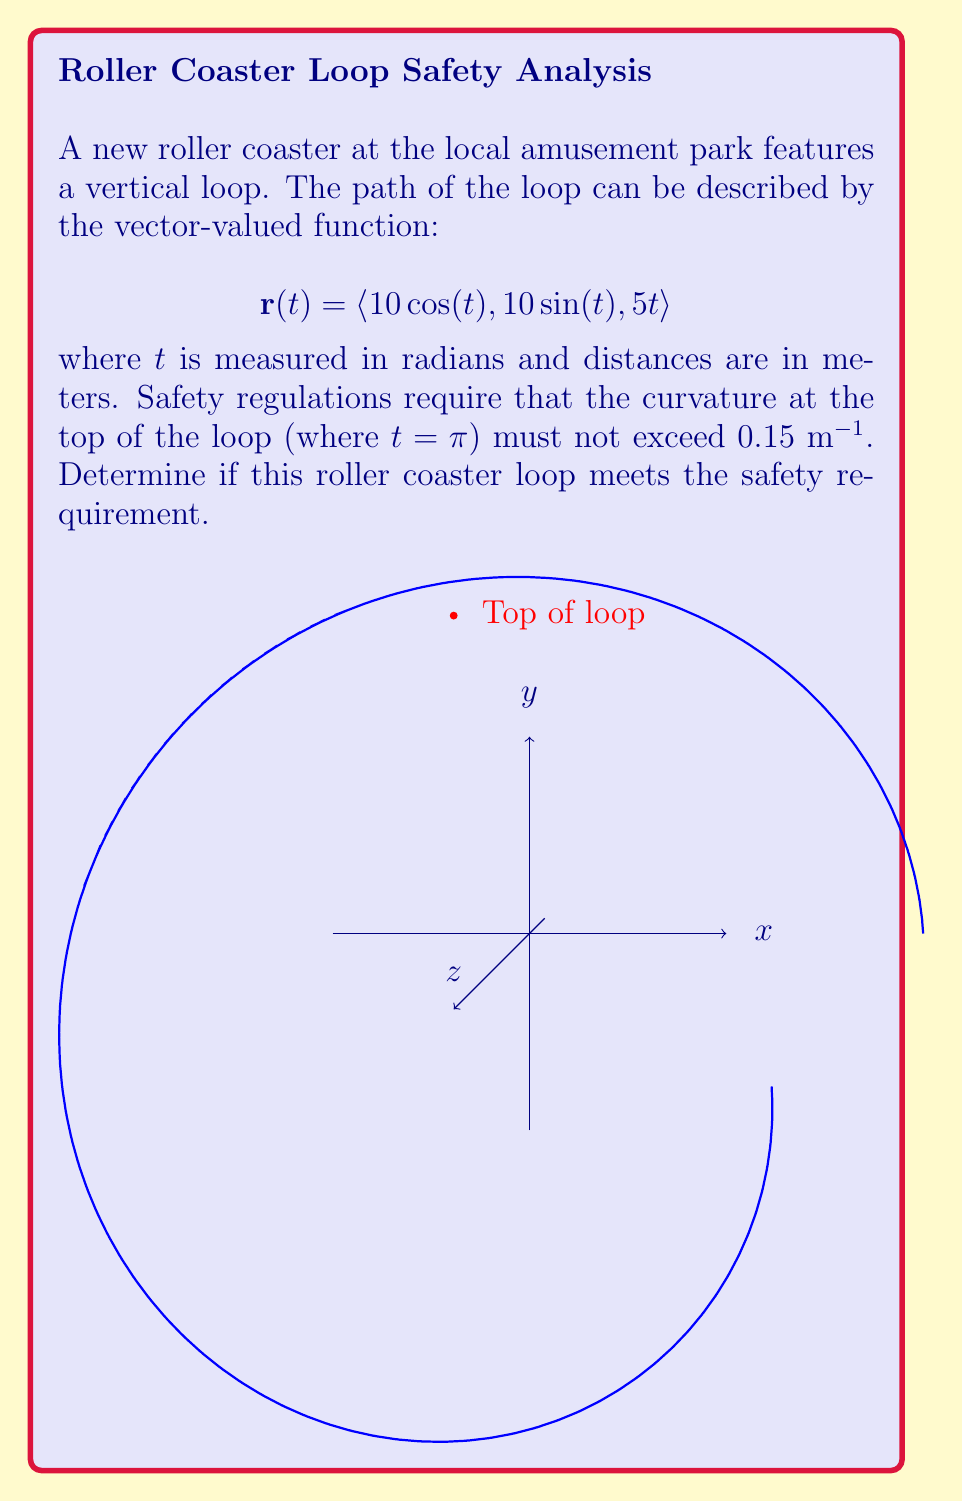What is the answer to this math problem? To determine if the roller coaster loop meets the safety requirement, we need to calculate the curvature at the top of the loop and compare it to the maximum allowed value. Let's follow these steps:

1) The curvature $\kappa$ of a curve defined by a vector-valued function $\mathbf{r}(t)$ is given by:

   $$\kappa = \frac{|\mathbf{r}'(t) \times \mathbf{r}''(t)|}{|\mathbf{r}'(t)|^3}$$

2) First, let's find $\mathbf{r}'(t)$:
   $$\mathbf{r}'(t) = \langle -10\sin(t), 10\cos(t), 5 \rangle$$

3) Now, let's find $\mathbf{r}''(t)$:
   $$\mathbf{r}''(t) = \langle -10\cos(t), -10\sin(t), 0 \rangle$$

4) At the top of the loop, $t = \pi$. Let's evaluate $\mathbf{r}'(\pi)$ and $\mathbf{r}''(\pi)$:
   $$\mathbf{r}'(\pi) = \langle 0, -10, 5 \rangle$$
   $$\mathbf{r}''(\pi) = \langle 10, 0, 0 \rangle$$

5) Now, let's calculate $\mathbf{r}'(\pi) \times \mathbf{r}''(\pi)$:
   $$\mathbf{r}'(\pi) \times \mathbf{r}''(\pi) = \langle 50, 100, 100 \rangle$$

6) Calculate the magnitudes:
   $$|\mathbf{r}'(\pi) \times \mathbf{r}''(\pi)| = \sqrt{50^2 + 100^2 + 100^2} = 150$$
   $$|\mathbf{r}'(\pi)| = \sqrt{0^2 + (-10)^2 + 5^2} = \sqrt{125} = 5\sqrt{5}$$

7) Now we can calculate the curvature:
   $$\kappa = \frac{150}{(5\sqrt{5})^3} = \frac{150}{625\sqrt{5}} = \frac{6}{25\sqrt{5}} \approx 0.1072$$

8) Compare this to the maximum allowed curvature of 0.15 m^(-1).

   0.1072 m^(-1) < 0.15 m^(-1)

Therefore, the curvature at the top of the loop is less than the maximum allowed value, so the roller coaster meets the safety requirement.
Answer: Yes, the roller coaster meets the safety requirement. The curvature at the top of the loop is approximately 0.1072 m^(-1), which is less than the maximum allowed 0.15 m^(-1). 